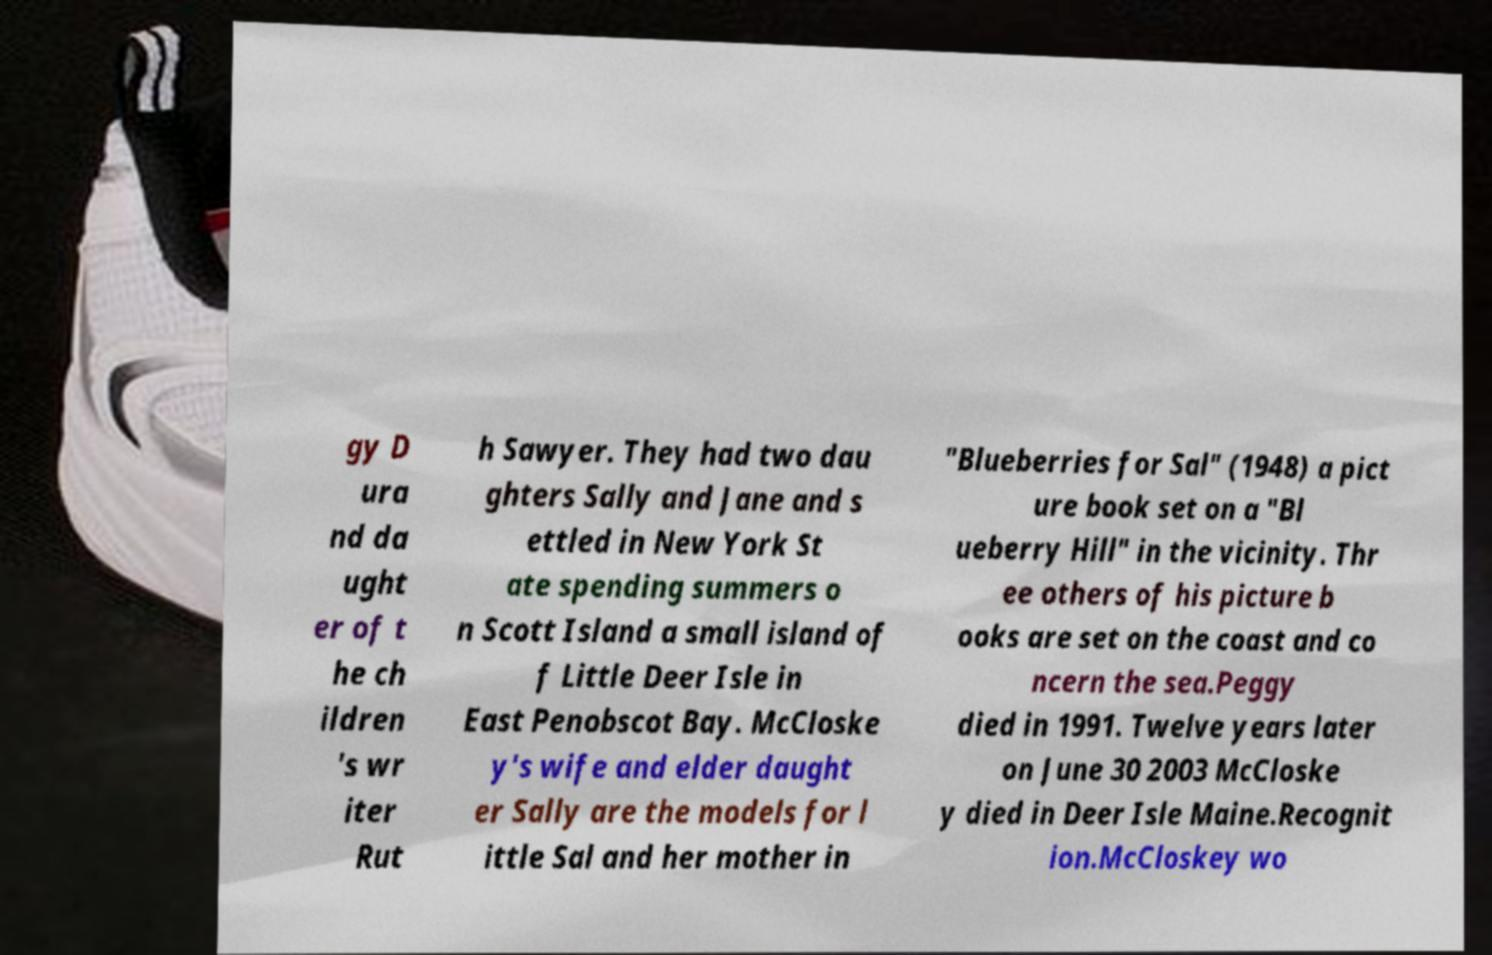For documentation purposes, I need the text within this image transcribed. Could you provide that? gy D ura nd da ught er of t he ch ildren 's wr iter Rut h Sawyer. They had two dau ghters Sally and Jane and s ettled in New York St ate spending summers o n Scott Island a small island of f Little Deer Isle in East Penobscot Bay. McCloske y's wife and elder daught er Sally are the models for l ittle Sal and her mother in "Blueberries for Sal" (1948) a pict ure book set on a "Bl ueberry Hill" in the vicinity. Thr ee others of his picture b ooks are set on the coast and co ncern the sea.Peggy died in 1991. Twelve years later on June 30 2003 McCloske y died in Deer Isle Maine.Recognit ion.McCloskey wo 